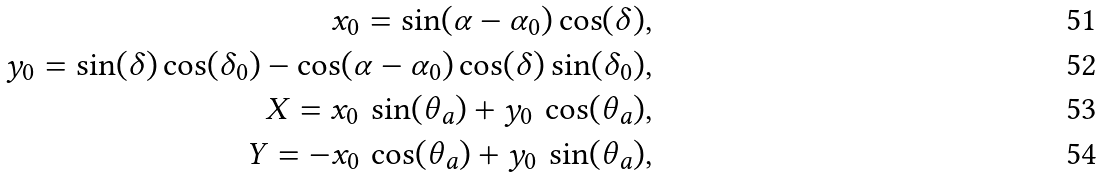Convert formula to latex. <formula><loc_0><loc_0><loc_500><loc_500>x _ { 0 } = \sin ( \alpha - \alpha _ { 0 } ) \cos ( \delta ) , \\ y _ { 0 } = \sin ( \delta ) \cos ( \delta _ { 0 } ) - \cos ( \alpha - \alpha _ { 0 } ) \cos ( \delta ) \sin ( \delta _ { 0 } ) , \\ X = x _ { 0 } \, \sin ( \theta _ { a } ) + y _ { 0 } \, \cos ( \theta _ { a } ) , \\ Y = - x _ { 0 } \, \cos ( \theta _ { a } ) + y _ { 0 } \, \sin ( \theta _ { a } ) ,</formula> 